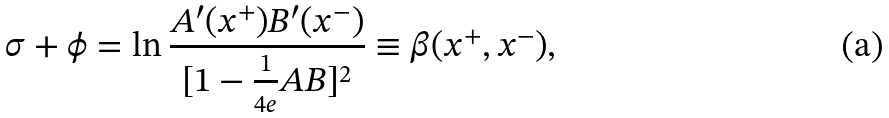<formula> <loc_0><loc_0><loc_500><loc_500>\sigma + \phi = \ln { \frac { A ^ { \prime } ( x ^ { + } ) B ^ { \prime } ( x ^ { - } ) } { [ 1 - { \frac { 1 } { 4 e } } A B ] ^ { 2 } } } \equiv \beta ( x ^ { + } , x ^ { - } ) ,</formula> 